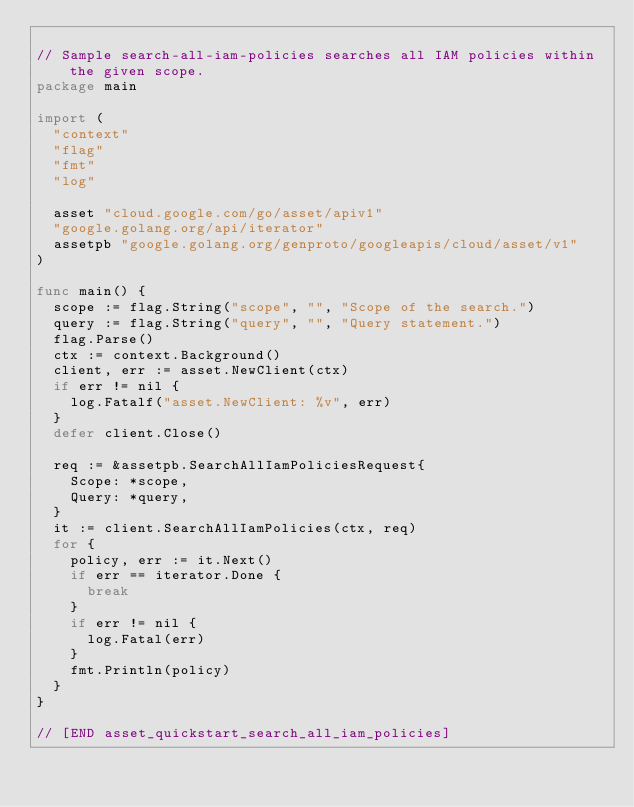Convert code to text. <code><loc_0><loc_0><loc_500><loc_500><_Go_>
// Sample search-all-iam-policies searches all IAM policies within the given scope.
package main

import (
	"context"
	"flag"
	"fmt"
	"log"

	asset "cloud.google.com/go/asset/apiv1"
	"google.golang.org/api/iterator"
	assetpb "google.golang.org/genproto/googleapis/cloud/asset/v1"
)

func main() {
	scope := flag.String("scope", "", "Scope of the search.")
	query := flag.String("query", "", "Query statement.")
	flag.Parse()
	ctx := context.Background()
	client, err := asset.NewClient(ctx)
	if err != nil {
		log.Fatalf("asset.NewClient: %v", err)
	}
	defer client.Close()

	req := &assetpb.SearchAllIamPoliciesRequest{
		Scope: *scope,
		Query: *query,
	}
	it := client.SearchAllIamPolicies(ctx, req)
	for {
		policy, err := it.Next()
		if err == iterator.Done {
			break
		}
		if err != nil {
			log.Fatal(err)
		}
		fmt.Println(policy)
	}
}

// [END asset_quickstart_search_all_iam_policies]
</code> 